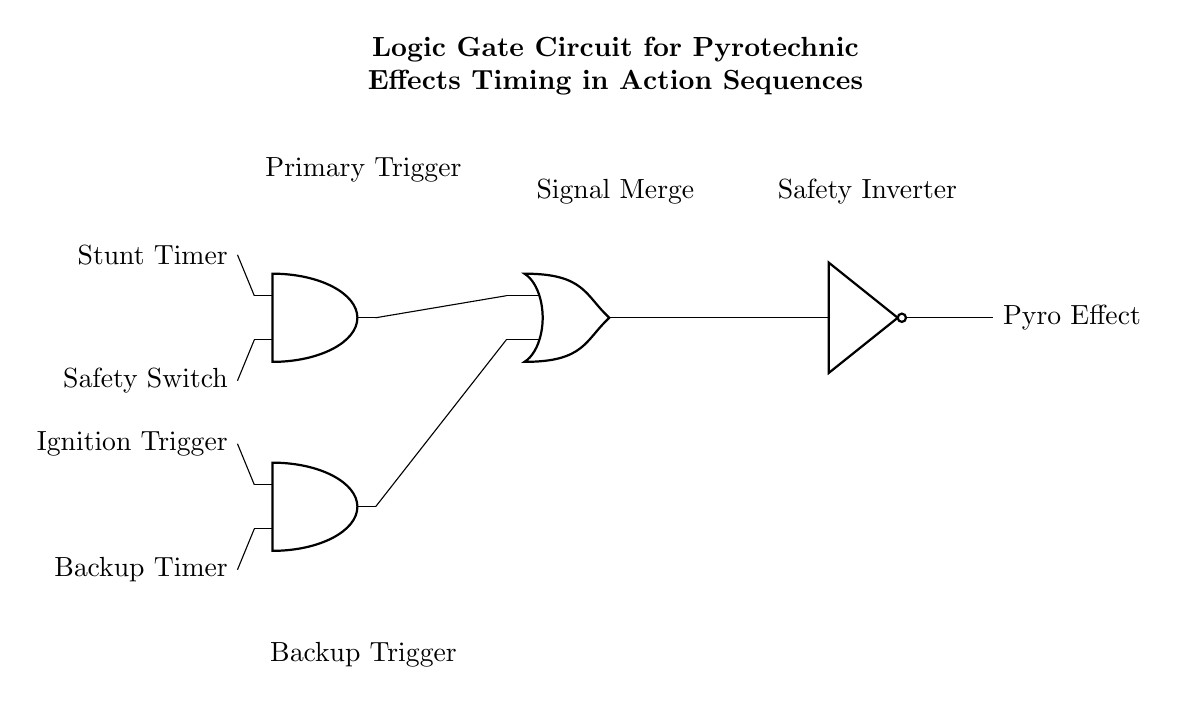What are the main components of this circuit? The circuit consists of two AND gates, one OR gate, and one NOT gate. Each gate serves a specific function in processing the signals from the inputs.
Answer: AND gates, OR gate, NOT gate What are the two types of triggers used in this circuit? The two types of triggers are the Ignition Trigger and the Backup Timer. These inputs are designed to initiate the pyrotechnic effects under different conditions.
Answer: Ignition Trigger, Backup Timer What is the output of the circuit? The output of the circuit is the Pyro Effect, which is activated based on the conditions met by the inputs and gates.
Answer: Pyro Effect How many inputs does the AND gate have? Each AND gate has two inputs as indicated by the circuit diagram showing the connection points for multiple signals.
Answer: Two inputs What is the function of the NOT gate in this circuit? The NOT gate negates the output from the OR gate, which means it inverts the signal to either allow or prevent the Pyro Effect from being activated based on the conditions set by the preceding gates.
Answer: Signal inversion Under what conditions will the Pyro Effect be activated? The Pyro Effect will be activated when at least one of the AND gates provides a high output, meaning either the Stunt Timer and Safety Switch conditions or the Ignition Trigger and Backup Timer conditions are satisfied, with the NOT gate ultimately inverting this signal.
Answer: At least one AND gate high output 